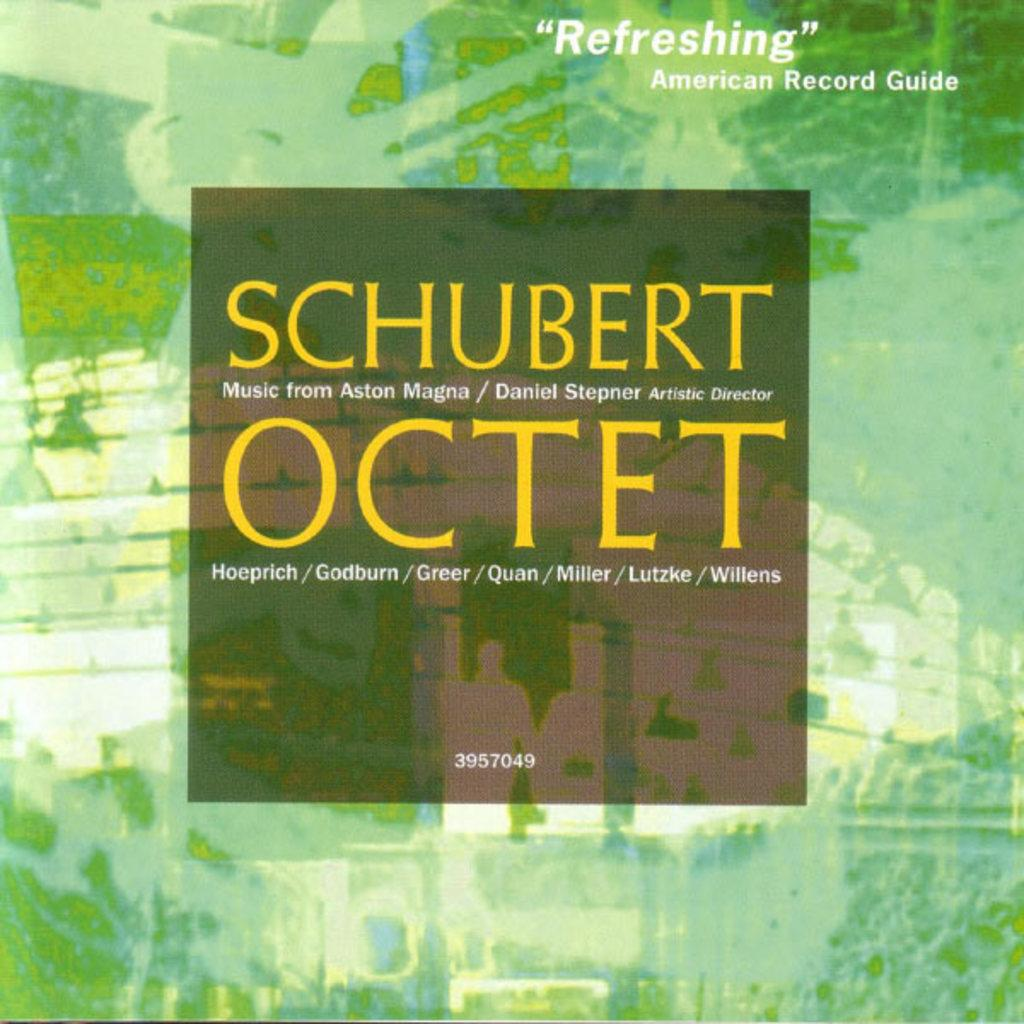What type of image is being described? The image is a poster. What can be found in the center of the poster? There is text in the center of the poster. Is there any text located elsewhere on the poster? Yes, there is text at the top of the poster. How many trees are depicted on the poster? There are no trees depicted on the poster; it is a text-based poster. What type of knowledge can be gained from the clocks on the poster? There are no clocks present on the poster, so no knowledge can be gained from them. 